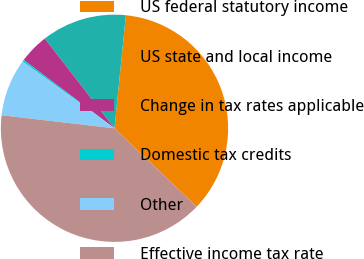<chart> <loc_0><loc_0><loc_500><loc_500><pie_chart><fcel>US federal statutory income<fcel>US state and local income<fcel>Change in tax rates applicable<fcel>Domestic tax credits<fcel>Other<fcel>Effective income tax rate<nl><fcel>35.51%<fcel>12.11%<fcel>4.22%<fcel>0.27%<fcel>8.17%<fcel>39.71%<nl></chart> 